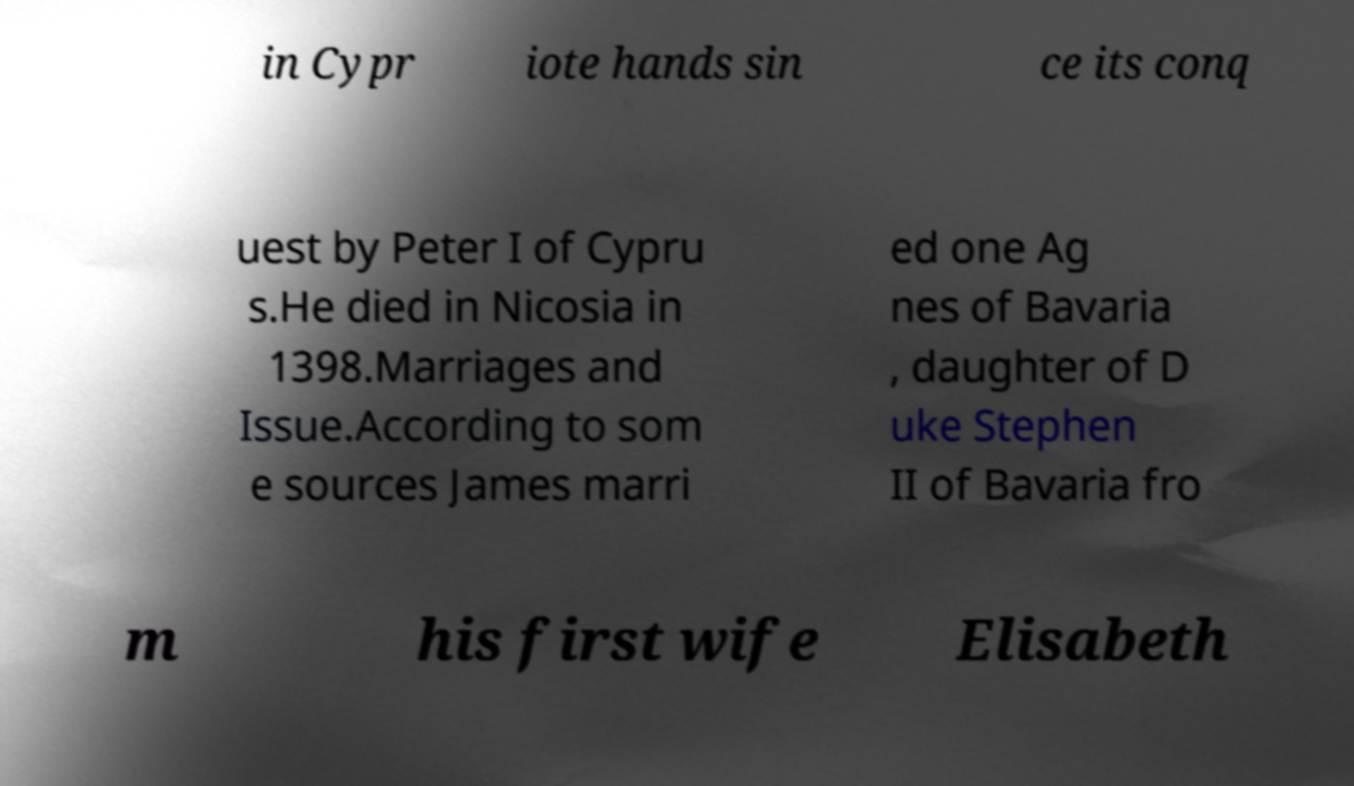Please read and relay the text visible in this image. What does it say? in Cypr iote hands sin ce its conq uest by Peter I of Cypru s.He died in Nicosia in 1398.Marriages and Issue.According to som e sources James marri ed one Ag nes of Bavaria , daughter of D uke Stephen II of Bavaria fro m his first wife Elisabeth 